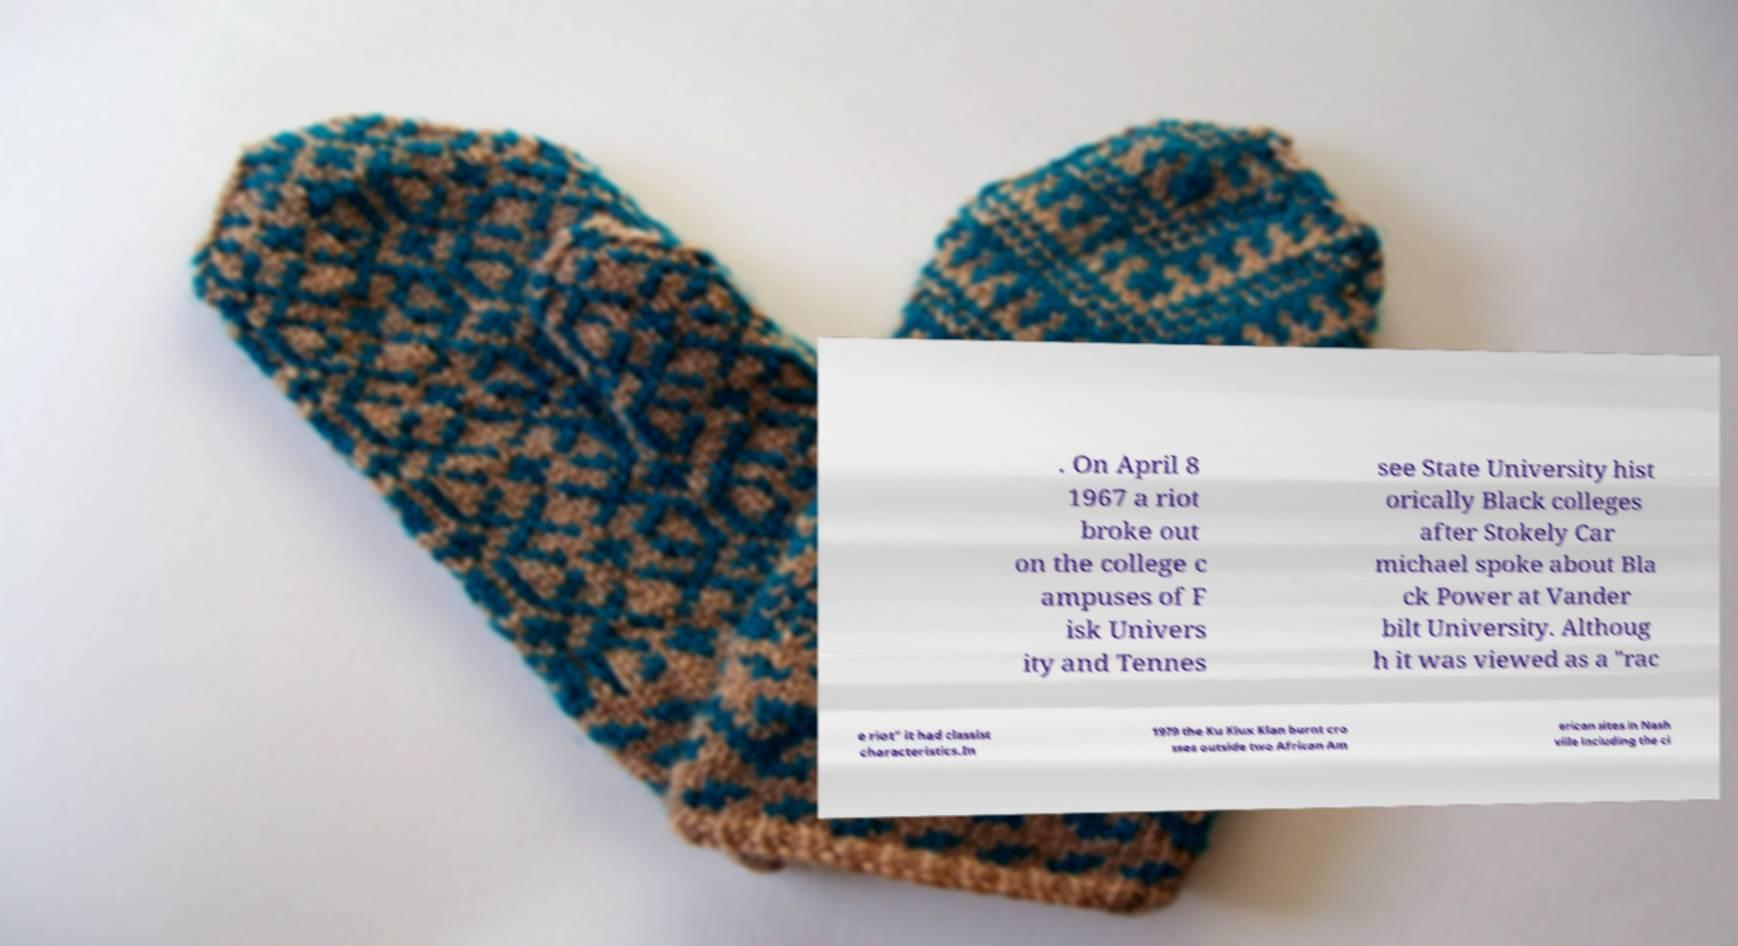Could you extract and type out the text from this image? . On April 8 1967 a riot broke out on the college c ampuses of F isk Univers ity and Tennes see State University hist orically Black colleges after Stokely Car michael spoke about Bla ck Power at Vander bilt University. Althoug h it was viewed as a "rac e riot" it had classist characteristics.In 1979 the Ku Klux Klan burnt cro sses outside two African Am erican sites in Nash ville including the ci 